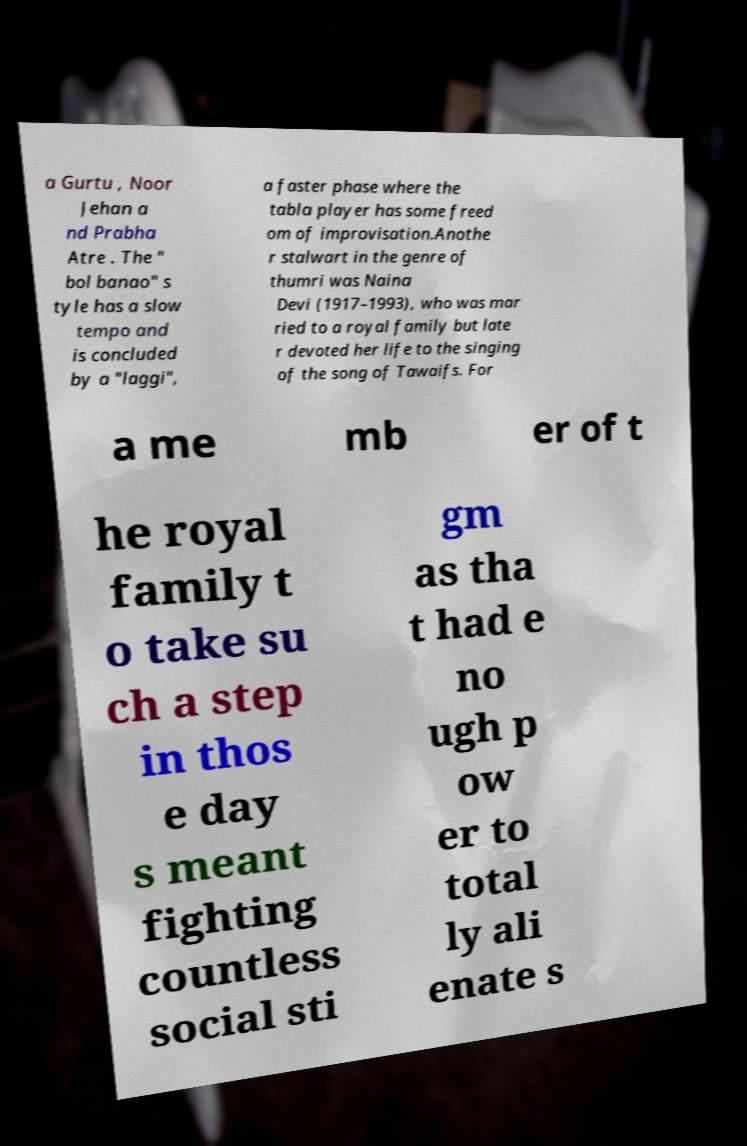Please identify and transcribe the text found in this image. a Gurtu , Noor Jehan a nd Prabha Atre . The " bol banao" s tyle has a slow tempo and is concluded by a "laggi", a faster phase where the tabla player has some freed om of improvisation.Anothe r stalwart in the genre of thumri was Naina Devi (1917–1993), who was mar ried to a royal family but late r devoted her life to the singing of the song of Tawaifs. For a me mb er of t he royal family t o take su ch a step in thos e day s meant fighting countless social sti gm as tha t had e no ugh p ow er to total ly ali enate s 